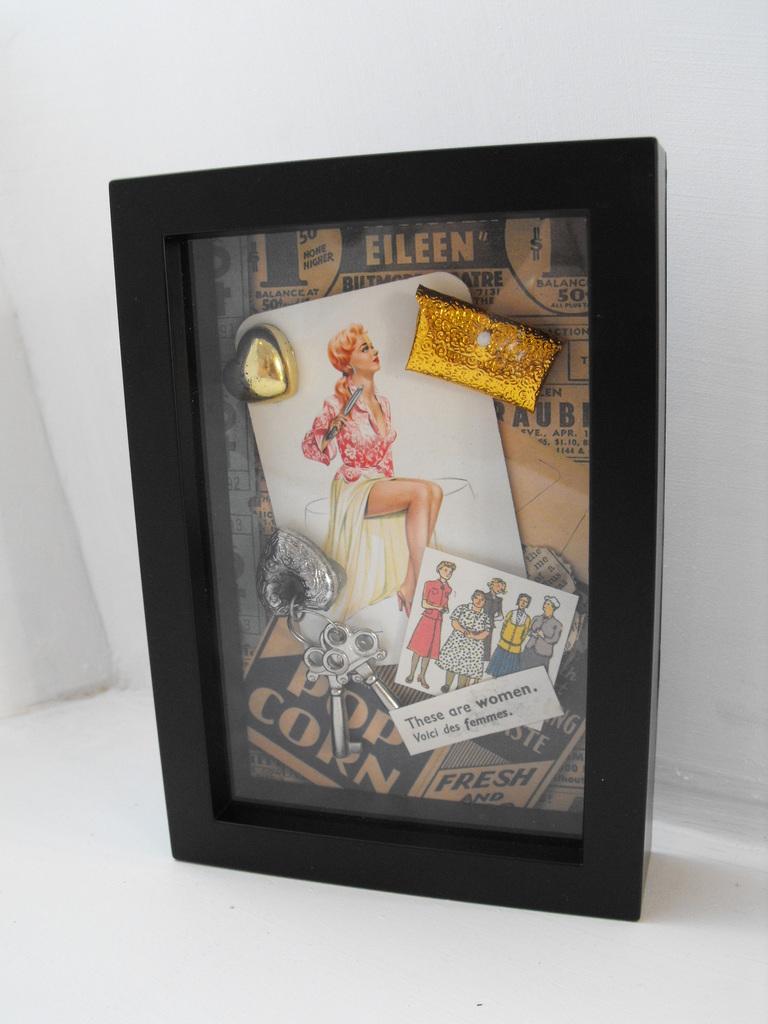What does it say in the bottom left corner?
Ensure brevity in your answer.  Pop corn. Was the popcorn fresh?
Your answer should be compact. Yes. 